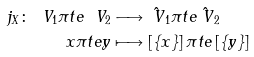<formula> <loc_0><loc_0><loc_500><loc_500>j _ { X } \colon \ V _ { 1 } \pi t e \ V _ { 2 } & \longrightarrow \hat { \ V } _ { 1 } \pi t e \hat { \ V } _ { 2 } \\ x \pi t e y & \longmapsto \left [ \{ x \} \right ] \pi t e \left [ \{ y \} \right ]</formula> 